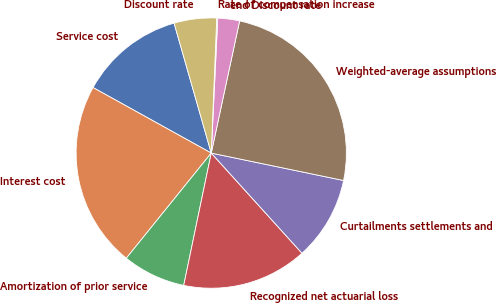<chart> <loc_0><loc_0><loc_500><loc_500><pie_chart><fcel>Service cost<fcel>Interest cost<fcel>Amortization of prior service<fcel>Recognized net actuarial loss<fcel>Curtailments settlements and<fcel>Weighted-average assumptions<fcel>end Discount rate<fcel>Rate of compensation increase<fcel>Discount rate<nl><fcel>12.51%<fcel>22.24%<fcel>7.55%<fcel>14.98%<fcel>10.03%<fcel>24.89%<fcel>2.6%<fcel>0.12%<fcel>5.08%<nl></chart> 